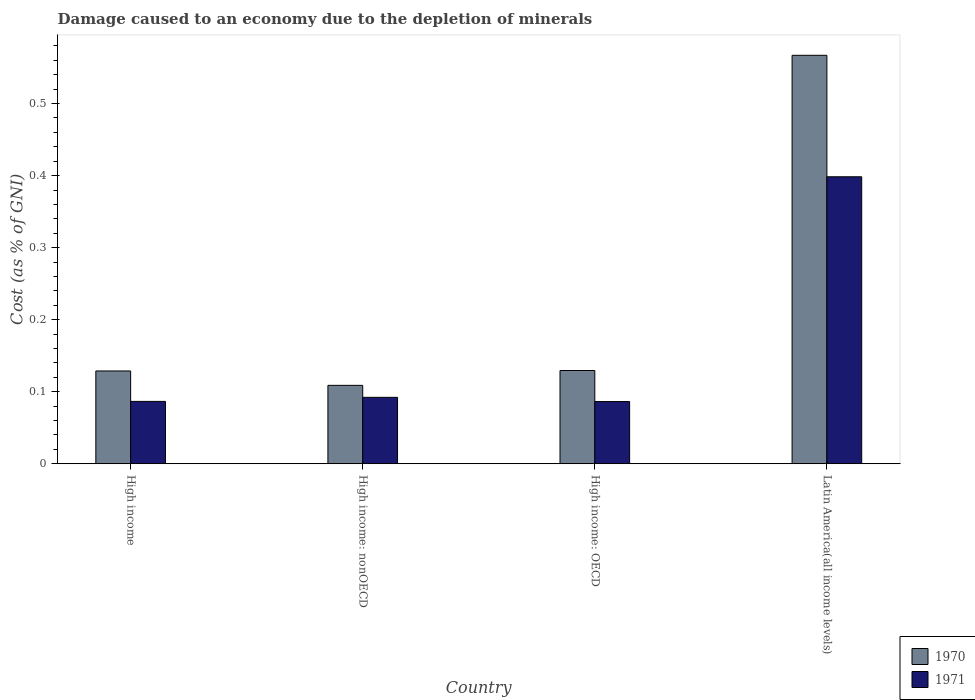How many groups of bars are there?
Keep it short and to the point. 4. Are the number of bars per tick equal to the number of legend labels?
Provide a succinct answer. Yes. How many bars are there on the 1st tick from the right?
Give a very brief answer. 2. In how many cases, is the number of bars for a given country not equal to the number of legend labels?
Provide a succinct answer. 0. What is the cost of damage caused due to the depletion of minerals in 1970 in High income: OECD?
Give a very brief answer. 0.13. Across all countries, what is the maximum cost of damage caused due to the depletion of minerals in 1971?
Offer a terse response. 0.4. Across all countries, what is the minimum cost of damage caused due to the depletion of minerals in 1971?
Ensure brevity in your answer.  0.09. In which country was the cost of damage caused due to the depletion of minerals in 1970 maximum?
Give a very brief answer. Latin America(all income levels). In which country was the cost of damage caused due to the depletion of minerals in 1970 minimum?
Your answer should be compact. High income: nonOECD. What is the total cost of damage caused due to the depletion of minerals in 1971 in the graph?
Offer a very short reply. 0.66. What is the difference between the cost of damage caused due to the depletion of minerals in 1971 in High income: OECD and that in Latin America(all income levels)?
Give a very brief answer. -0.31. What is the difference between the cost of damage caused due to the depletion of minerals in 1971 in High income: OECD and the cost of damage caused due to the depletion of minerals in 1970 in High income: nonOECD?
Ensure brevity in your answer.  -0.02. What is the average cost of damage caused due to the depletion of minerals in 1970 per country?
Provide a succinct answer. 0.23. What is the difference between the cost of damage caused due to the depletion of minerals of/in 1971 and cost of damage caused due to the depletion of minerals of/in 1970 in Latin America(all income levels)?
Keep it short and to the point. -0.17. What is the ratio of the cost of damage caused due to the depletion of minerals in 1971 in High income to that in Latin America(all income levels)?
Your answer should be compact. 0.22. Is the cost of damage caused due to the depletion of minerals in 1971 in High income less than that in High income: OECD?
Offer a terse response. No. Is the difference between the cost of damage caused due to the depletion of minerals in 1971 in High income and High income: nonOECD greater than the difference between the cost of damage caused due to the depletion of minerals in 1970 in High income and High income: nonOECD?
Provide a short and direct response. No. What is the difference between the highest and the second highest cost of damage caused due to the depletion of minerals in 1971?
Make the answer very short. 0.31. What is the difference between the highest and the lowest cost of damage caused due to the depletion of minerals in 1971?
Offer a very short reply. 0.31. Is the sum of the cost of damage caused due to the depletion of minerals in 1971 in High income and High income: nonOECD greater than the maximum cost of damage caused due to the depletion of minerals in 1970 across all countries?
Your answer should be compact. No. What does the 1st bar from the left in High income represents?
Offer a terse response. 1970. Are all the bars in the graph horizontal?
Ensure brevity in your answer.  No. How many countries are there in the graph?
Keep it short and to the point. 4. Does the graph contain any zero values?
Give a very brief answer. No. How are the legend labels stacked?
Your response must be concise. Vertical. What is the title of the graph?
Ensure brevity in your answer.  Damage caused to an economy due to the depletion of minerals. Does "1992" appear as one of the legend labels in the graph?
Make the answer very short. No. What is the label or title of the Y-axis?
Give a very brief answer. Cost (as % of GNI). What is the Cost (as % of GNI) in 1970 in High income?
Make the answer very short. 0.13. What is the Cost (as % of GNI) in 1971 in High income?
Your response must be concise. 0.09. What is the Cost (as % of GNI) of 1970 in High income: nonOECD?
Give a very brief answer. 0.11. What is the Cost (as % of GNI) of 1971 in High income: nonOECD?
Ensure brevity in your answer.  0.09. What is the Cost (as % of GNI) of 1970 in High income: OECD?
Your answer should be very brief. 0.13. What is the Cost (as % of GNI) of 1971 in High income: OECD?
Provide a short and direct response. 0.09. What is the Cost (as % of GNI) of 1970 in Latin America(all income levels)?
Give a very brief answer. 0.57. What is the Cost (as % of GNI) in 1971 in Latin America(all income levels)?
Provide a succinct answer. 0.4. Across all countries, what is the maximum Cost (as % of GNI) of 1970?
Provide a short and direct response. 0.57. Across all countries, what is the maximum Cost (as % of GNI) of 1971?
Your response must be concise. 0.4. Across all countries, what is the minimum Cost (as % of GNI) in 1970?
Your answer should be very brief. 0.11. Across all countries, what is the minimum Cost (as % of GNI) in 1971?
Give a very brief answer. 0.09. What is the total Cost (as % of GNI) of 1970 in the graph?
Give a very brief answer. 0.93. What is the total Cost (as % of GNI) in 1971 in the graph?
Provide a short and direct response. 0.66. What is the difference between the Cost (as % of GNI) of 1970 in High income and that in High income: nonOECD?
Give a very brief answer. 0.02. What is the difference between the Cost (as % of GNI) of 1971 in High income and that in High income: nonOECD?
Make the answer very short. -0.01. What is the difference between the Cost (as % of GNI) in 1970 in High income and that in High income: OECD?
Your response must be concise. -0. What is the difference between the Cost (as % of GNI) of 1971 in High income and that in High income: OECD?
Provide a succinct answer. 0. What is the difference between the Cost (as % of GNI) of 1970 in High income and that in Latin America(all income levels)?
Provide a succinct answer. -0.44. What is the difference between the Cost (as % of GNI) in 1971 in High income and that in Latin America(all income levels)?
Provide a short and direct response. -0.31. What is the difference between the Cost (as % of GNI) in 1970 in High income: nonOECD and that in High income: OECD?
Make the answer very short. -0.02. What is the difference between the Cost (as % of GNI) of 1971 in High income: nonOECD and that in High income: OECD?
Give a very brief answer. 0.01. What is the difference between the Cost (as % of GNI) of 1970 in High income: nonOECD and that in Latin America(all income levels)?
Your answer should be very brief. -0.46. What is the difference between the Cost (as % of GNI) of 1971 in High income: nonOECD and that in Latin America(all income levels)?
Your answer should be compact. -0.31. What is the difference between the Cost (as % of GNI) in 1970 in High income: OECD and that in Latin America(all income levels)?
Offer a very short reply. -0.44. What is the difference between the Cost (as % of GNI) of 1971 in High income: OECD and that in Latin America(all income levels)?
Ensure brevity in your answer.  -0.31. What is the difference between the Cost (as % of GNI) in 1970 in High income and the Cost (as % of GNI) in 1971 in High income: nonOECD?
Make the answer very short. 0.04. What is the difference between the Cost (as % of GNI) of 1970 in High income and the Cost (as % of GNI) of 1971 in High income: OECD?
Make the answer very short. 0.04. What is the difference between the Cost (as % of GNI) in 1970 in High income and the Cost (as % of GNI) in 1971 in Latin America(all income levels)?
Keep it short and to the point. -0.27. What is the difference between the Cost (as % of GNI) of 1970 in High income: nonOECD and the Cost (as % of GNI) of 1971 in High income: OECD?
Your response must be concise. 0.02. What is the difference between the Cost (as % of GNI) in 1970 in High income: nonOECD and the Cost (as % of GNI) in 1971 in Latin America(all income levels)?
Offer a terse response. -0.29. What is the difference between the Cost (as % of GNI) in 1970 in High income: OECD and the Cost (as % of GNI) in 1971 in Latin America(all income levels)?
Your answer should be very brief. -0.27. What is the average Cost (as % of GNI) of 1970 per country?
Your answer should be very brief. 0.23. What is the average Cost (as % of GNI) of 1971 per country?
Your answer should be compact. 0.17. What is the difference between the Cost (as % of GNI) in 1970 and Cost (as % of GNI) in 1971 in High income?
Ensure brevity in your answer.  0.04. What is the difference between the Cost (as % of GNI) of 1970 and Cost (as % of GNI) of 1971 in High income: nonOECD?
Offer a very short reply. 0.02. What is the difference between the Cost (as % of GNI) in 1970 and Cost (as % of GNI) in 1971 in High income: OECD?
Provide a short and direct response. 0.04. What is the difference between the Cost (as % of GNI) of 1970 and Cost (as % of GNI) of 1971 in Latin America(all income levels)?
Provide a succinct answer. 0.17. What is the ratio of the Cost (as % of GNI) of 1970 in High income to that in High income: nonOECD?
Offer a terse response. 1.18. What is the ratio of the Cost (as % of GNI) in 1971 in High income to that in High income: nonOECD?
Your answer should be very brief. 0.94. What is the ratio of the Cost (as % of GNI) of 1971 in High income to that in High income: OECD?
Provide a short and direct response. 1. What is the ratio of the Cost (as % of GNI) in 1970 in High income to that in Latin America(all income levels)?
Your answer should be very brief. 0.23. What is the ratio of the Cost (as % of GNI) of 1971 in High income to that in Latin America(all income levels)?
Provide a succinct answer. 0.22. What is the ratio of the Cost (as % of GNI) of 1970 in High income: nonOECD to that in High income: OECD?
Your answer should be compact. 0.84. What is the ratio of the Cost (as % of GNI) of 1971 in High income: nonOECD to that in High income: OECD?
Provide a short and direct response. 1.07. What is the ratio of the Cost (as % of GNI) of 1970 in High income: nonOECD to that in Latin America(all income levels)?
Your answer should be very brief. 0.19. What is the ratio of the Cost (as % of GNI) of 1971 in High income: nonOECD to that in Latin America(all income levels)?
Your response must be concise. 0.23. What is the ratio of the Cost (as % of GNI) of 1970 in High income: OECD to that in Latin America(all income levels)?
Give a very brief answer. 0.23. What is the ratio of the Cost (as % of GNI) in 1971 in High income: OECD to that in Latin America(all income levels)?
Give a very brief answer. 0.22. What is the difference between the highest and the second highest Cost (as % of GNI) in 1970?
Make the answer very short. 0.44. What is the difference between the highest and the second highest Cost (as % of GNI) of 1971?
Offer a terse response. 0.31. What is the difference between the highest and the lowest Cost (as % of GNI) in 1970?
Keep it short and to the point. 0.46. What is the difference between the highest and the lowest Cost (as % of GNI) in 1971?
Give a very brief answer. 0.31. 